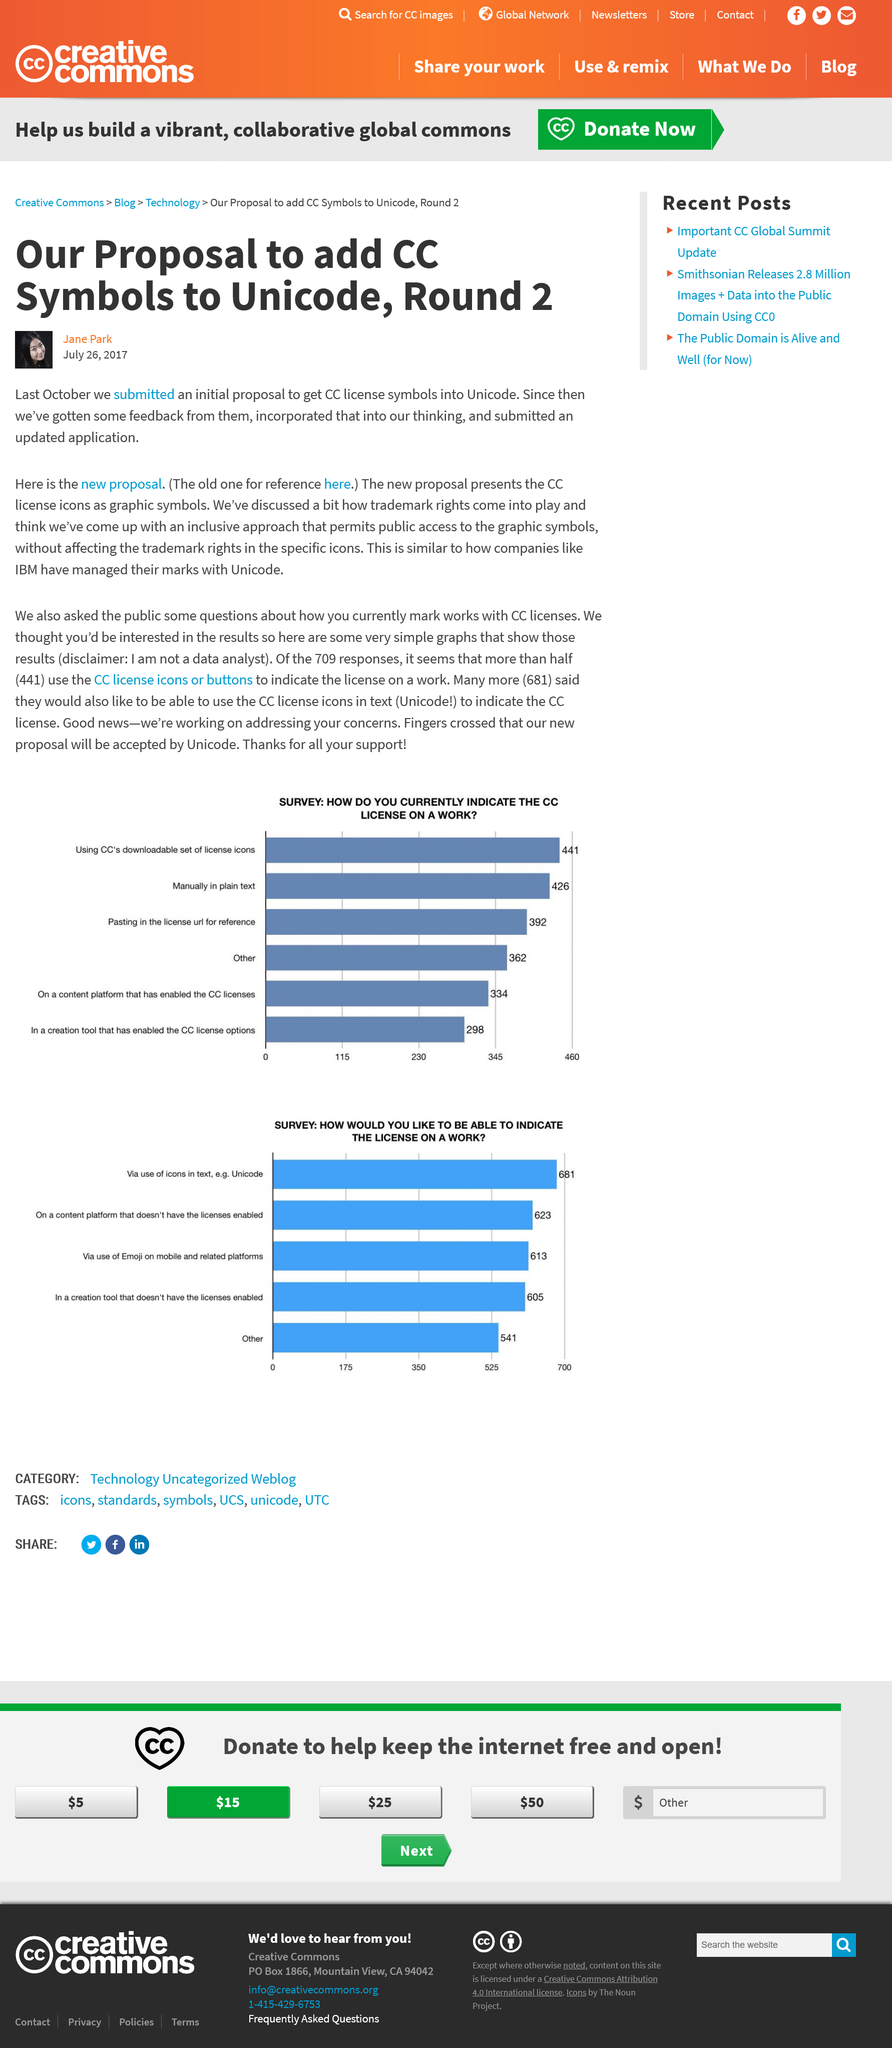Indicate a few pertinent items in this graphic. The new proposal describes the use of graphic symbols instead of Unicode for the CC license icons, while the old proposal used Unicode. We are currently on the third proposal in the round two process, as we submitted our initial proposal for review last October. The proposal was put forward on July 26, 2017. 